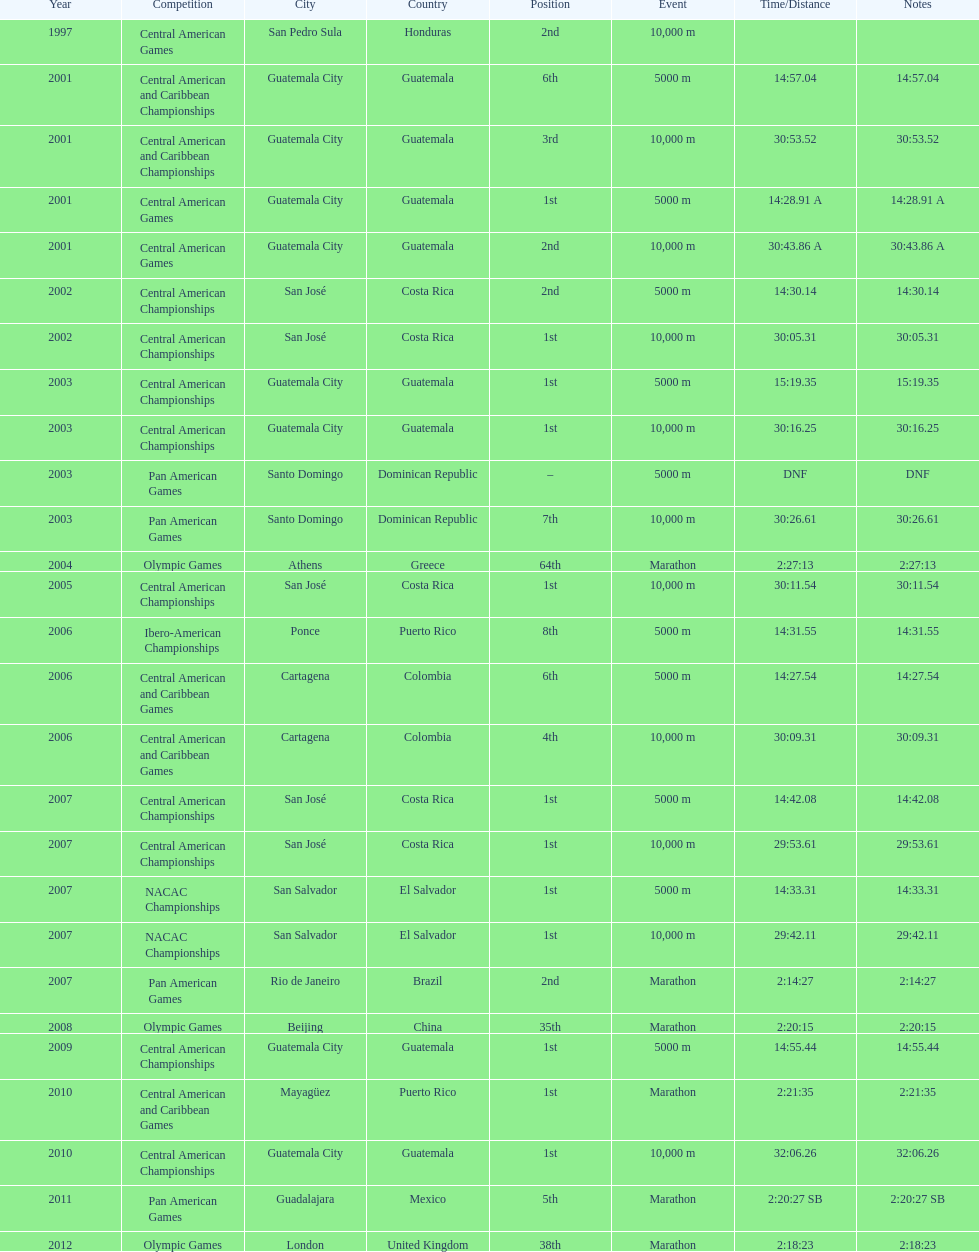The central american championships and what other competition occurred in 2010? Central American and Caribbean Games. 